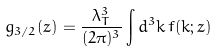Convert formula to latex. <formula><loc_0><loc_0><loc_500><loc_500>g _ { 3 / 2 } ( z ) = \frac { \lambda _ { T } ^ { 3 } } { ( 2 \pi ) ^ { 3 } } \int d ^ { 3 } k \, f ( k ; z )</formula> 